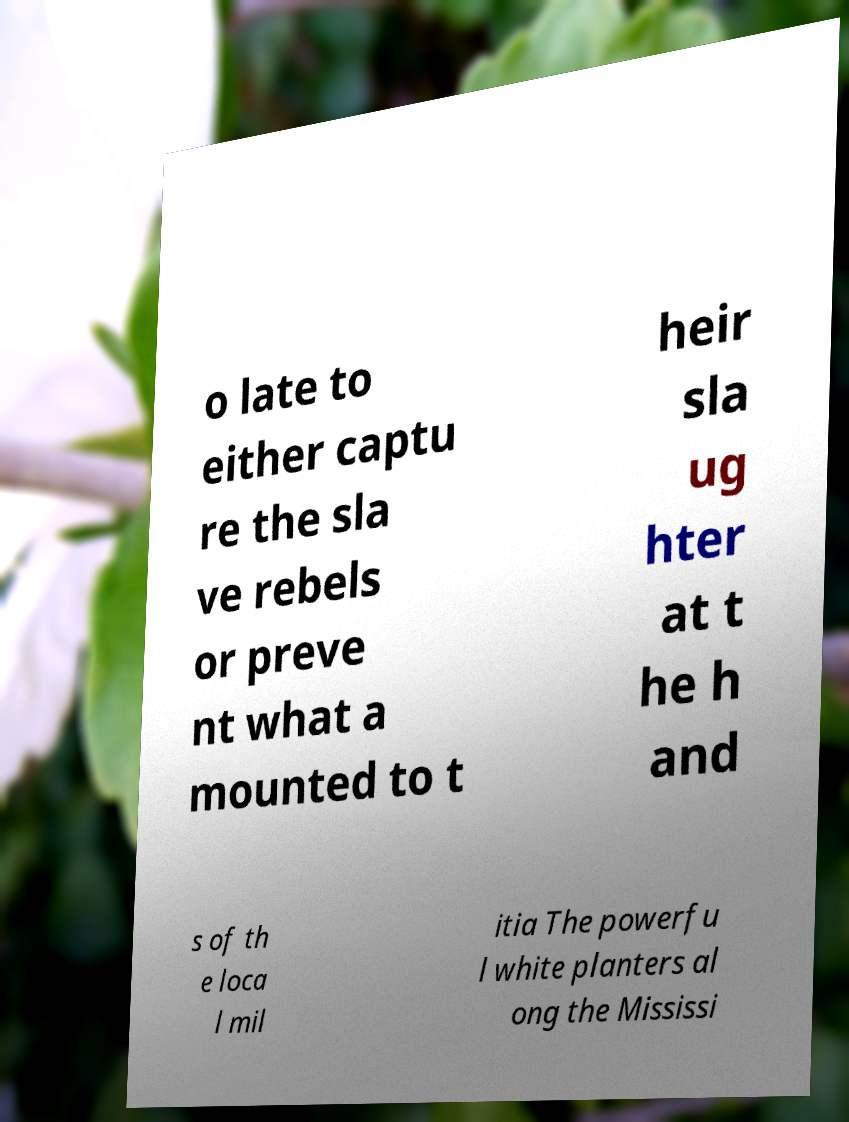There's text embedded in this image that I need extracted. Can you transcribe it verbatim? o late to either captu re the sla ve rebels or preve nt what a mounted to t heir sla ug hter at t he h and s of th e loca l mil itia The powerfu l white planters al ong the Mississi 